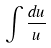<formula> <loc_0><loc_0><loc_500><loc_500>\int \frac { d u } { u }</formula> 